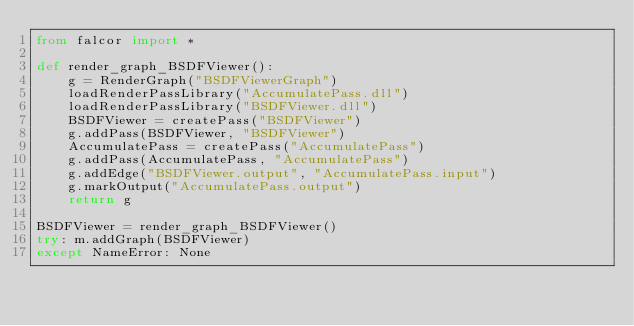<code> <loc_0><loc_0><loc_500><loc_500><_Python_>from falcor import *

def render_graph_BSDFViewer():
    g = RenderGraph("BSDFViewerGraph")
    loadRenderPassLibrary("AccumulatePass.dll")
    loadRenderPassLibrary("BSDFViewer.dll")
    BSDFViewer = createPass("BSDFViewer")
    g.addPass(BSDFViewer, "BSDFViewer")
    AccumulatePass = createPass("AccumulatePass")
    g.addPass(AccumulatePass, "AccumulatePass")
    g.addEdge("BSDFViewer.output", "AccumulatePass.input")
    g.markOutput("AccumulatePass.output")
    return g

BSDFViewer = render_graph_BSDFViewer()
try: m.addGraph(BSDFViewer)
except NameError: None
</code> 